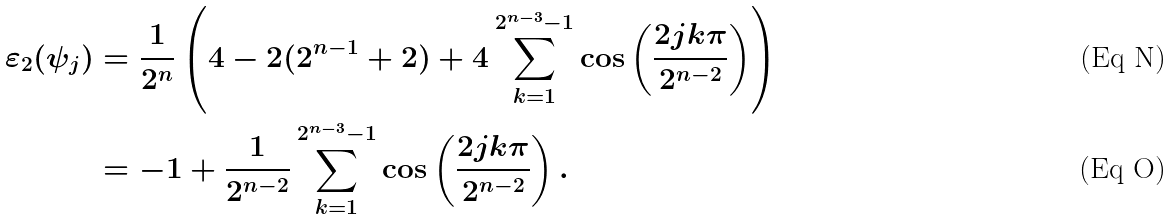<formula> <loc_0><loc_0><loc_500><loc_500>\varepsilon _ { 2 } ( \psi _ { j } ) & = \frac { 1 } { 2 ^ { n } } \left ( 4 - 2 ( 2 ^ { n - 1 } + 2 ) + 4 \sum _ { k = 1 } ^ { 2 ^ { n - 3 } - 1 } \cos \left ( \frac { 2 j k \pi } { 2 ^ { n - 2 } } \right ) \right ) \\ & = - 1 + \frac { 1 } { 2 ^ { n - 2 } } \sum _ { k = 1 } ^ { 2 ^ { n - 3 } - 1 } \cos \left ( \frac { 2 j k \pi } { 2 ^ { n - 2 } } \right ) .</formula> 